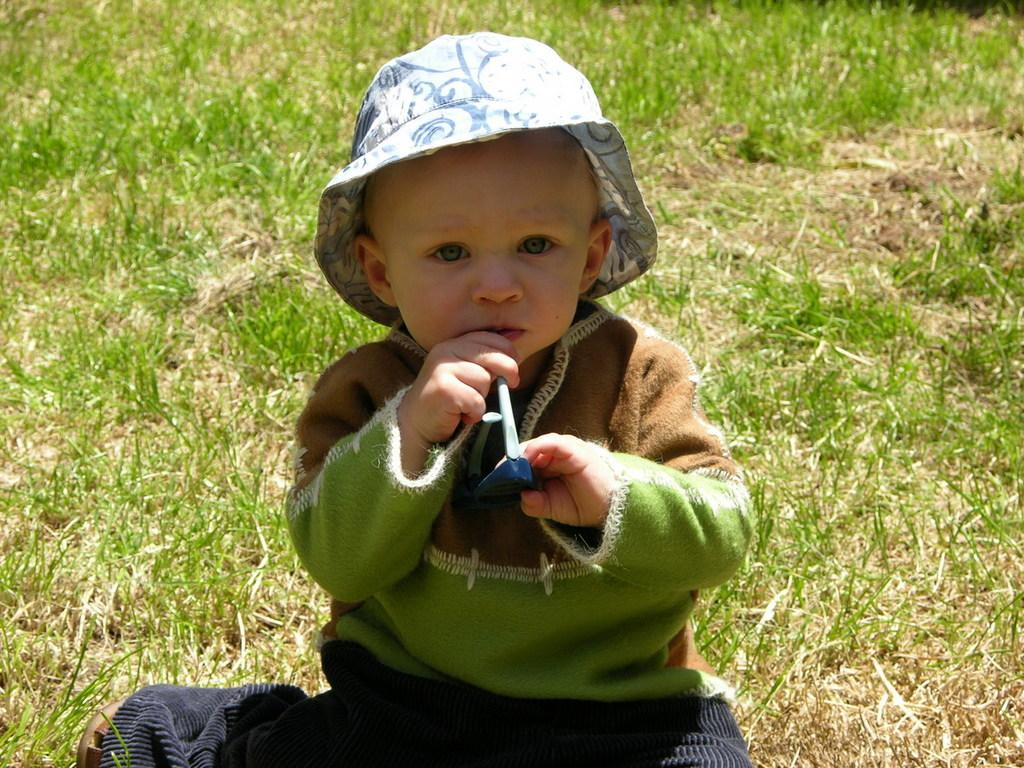Who is the main subject in the image? There is a boy in the image. What is the boy doing in the image? The boy is holding an object in his hands. What type of surface is visible at the bottom of the image? There is grass on the surface at the bottom of the image. What type of sheet is covering the boy in the image? There is no sheet covering the boy in the image. 